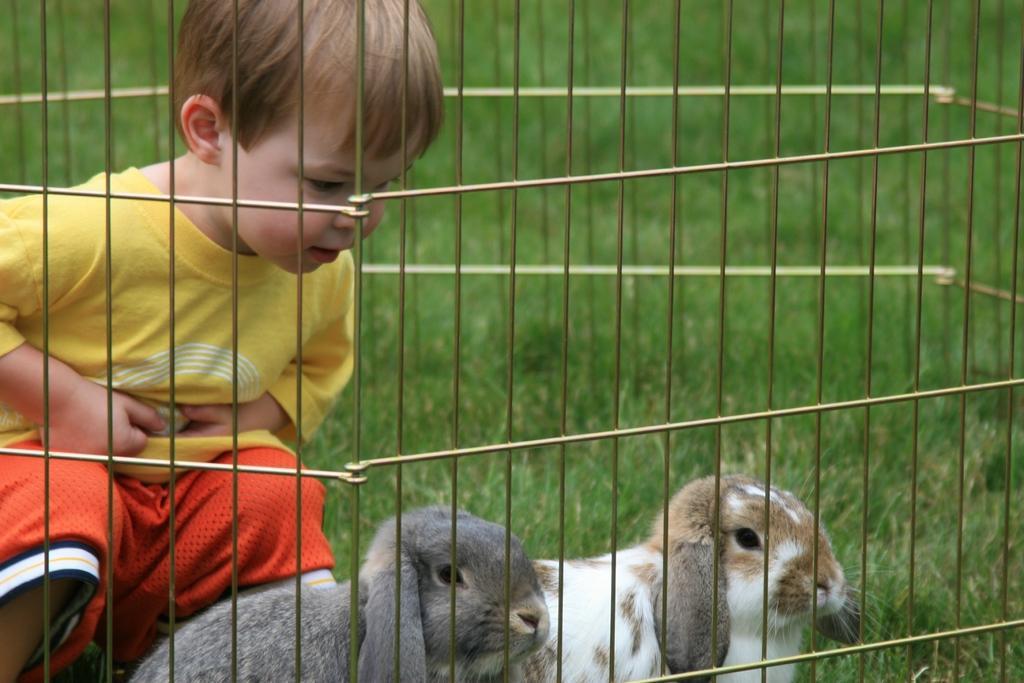Could you give a brief overview of what you see in this image? In this image on the left there is a boy, he wears a t shirt, trouser. At the bottom there is a box inside that there are two rabbits. In the background there is grass. 